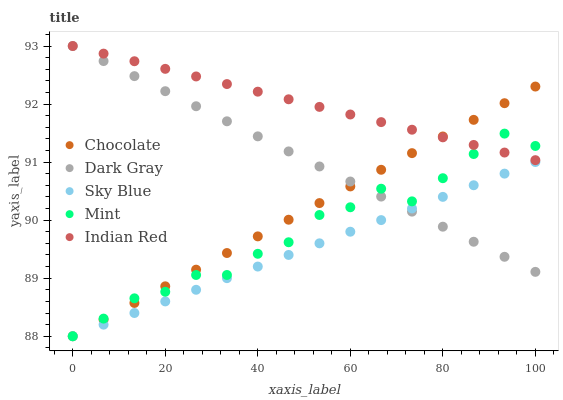Does Sky Blue have the minimum area under the curve?
Answer yes or no. Yes. Does Indian Red have the maximum area under the curve?
Answer yes or no. Yes. Does Mint have the minimum area under the curve?
Answer yes or no. No. Does Mint have the maximum area under the curve?
Answer yes or no. No. Is Dark Gray the smoothest?
Answer yes or no. Yes. Is Mint the roughest?
Answer yes or no. Yes. Is Sky Blue the smoothest?
Answer yes or no. No. Is Sky Blue the roughest?
Answer yes or no. No. Does Sky Blue have the lowest value?
Answer yes or no. Yes. Does Indian Red have the lowest value?
Answer yes or no. No. Does Indian Red have the highest value?
Answer yes or no. Yes. Does Mint have the highest value?
Answer yes or no. No. Is Sky Blue less than Indian Red?
Answer yes or no. Yes. Is Indian Red greater than Sky Blue?
Answer yes or no. Yes. Does Indian Red intersect Mint?
Answer yes or no. Yes. Is Indian Red less than Mint?
Answer yes or no. No. Is Indian Red greater than Mint?
Answer yes or no. No. Does Sky Blue intersect Indian Red?
Answer yes or no. No. 